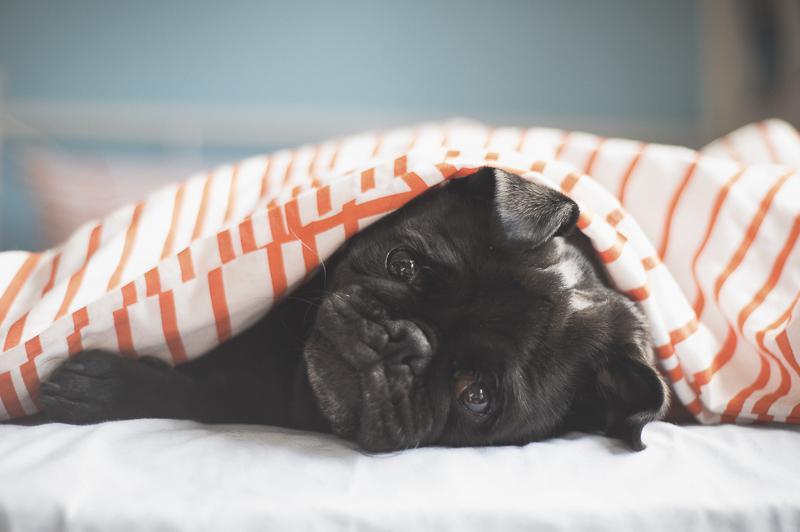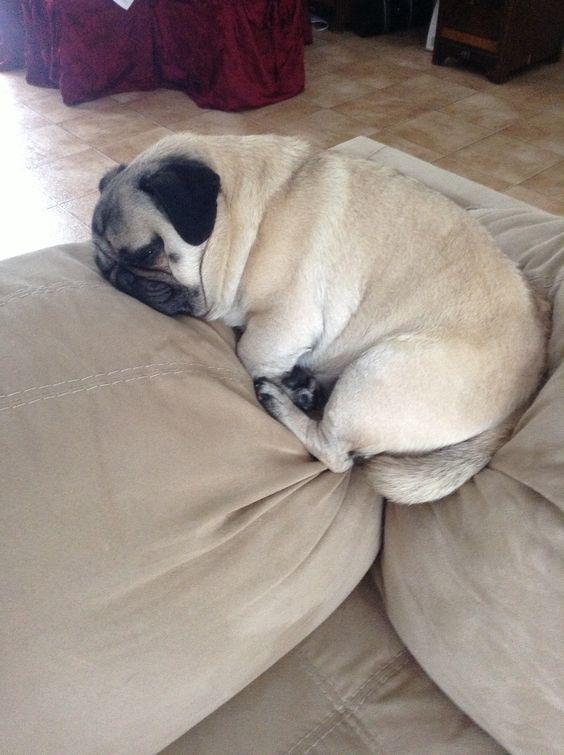The first image is the image on the left, the second image is the image on the right. For the images displayed, is the sentence "In the right image, the pug has no paws sticking out of the blanket." factually correct? Answer yes or no. No. The first image is the image on the left, the second image is the image on the right. Considering the images on both sides, is "A black pug lying with its head sideways is peeking out from under a sheet in the left image." valid? Answer yes or no. Yes. 